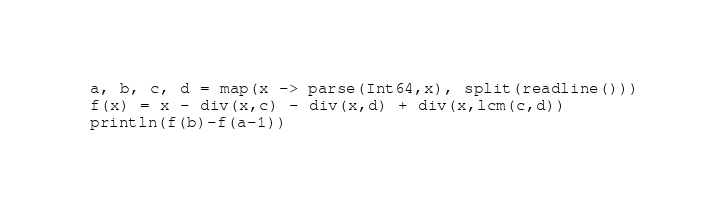<code> <loc_0><loc_0><loc_500><loc_500><_Julia_>a, b, c, d = map(x -> parse(Int64,x), split(readline()))
f(x) = x - div(x,c) - div(x,d) + div(x,lcm(c,d))
println(f(b)-f(a-1))
</code> 